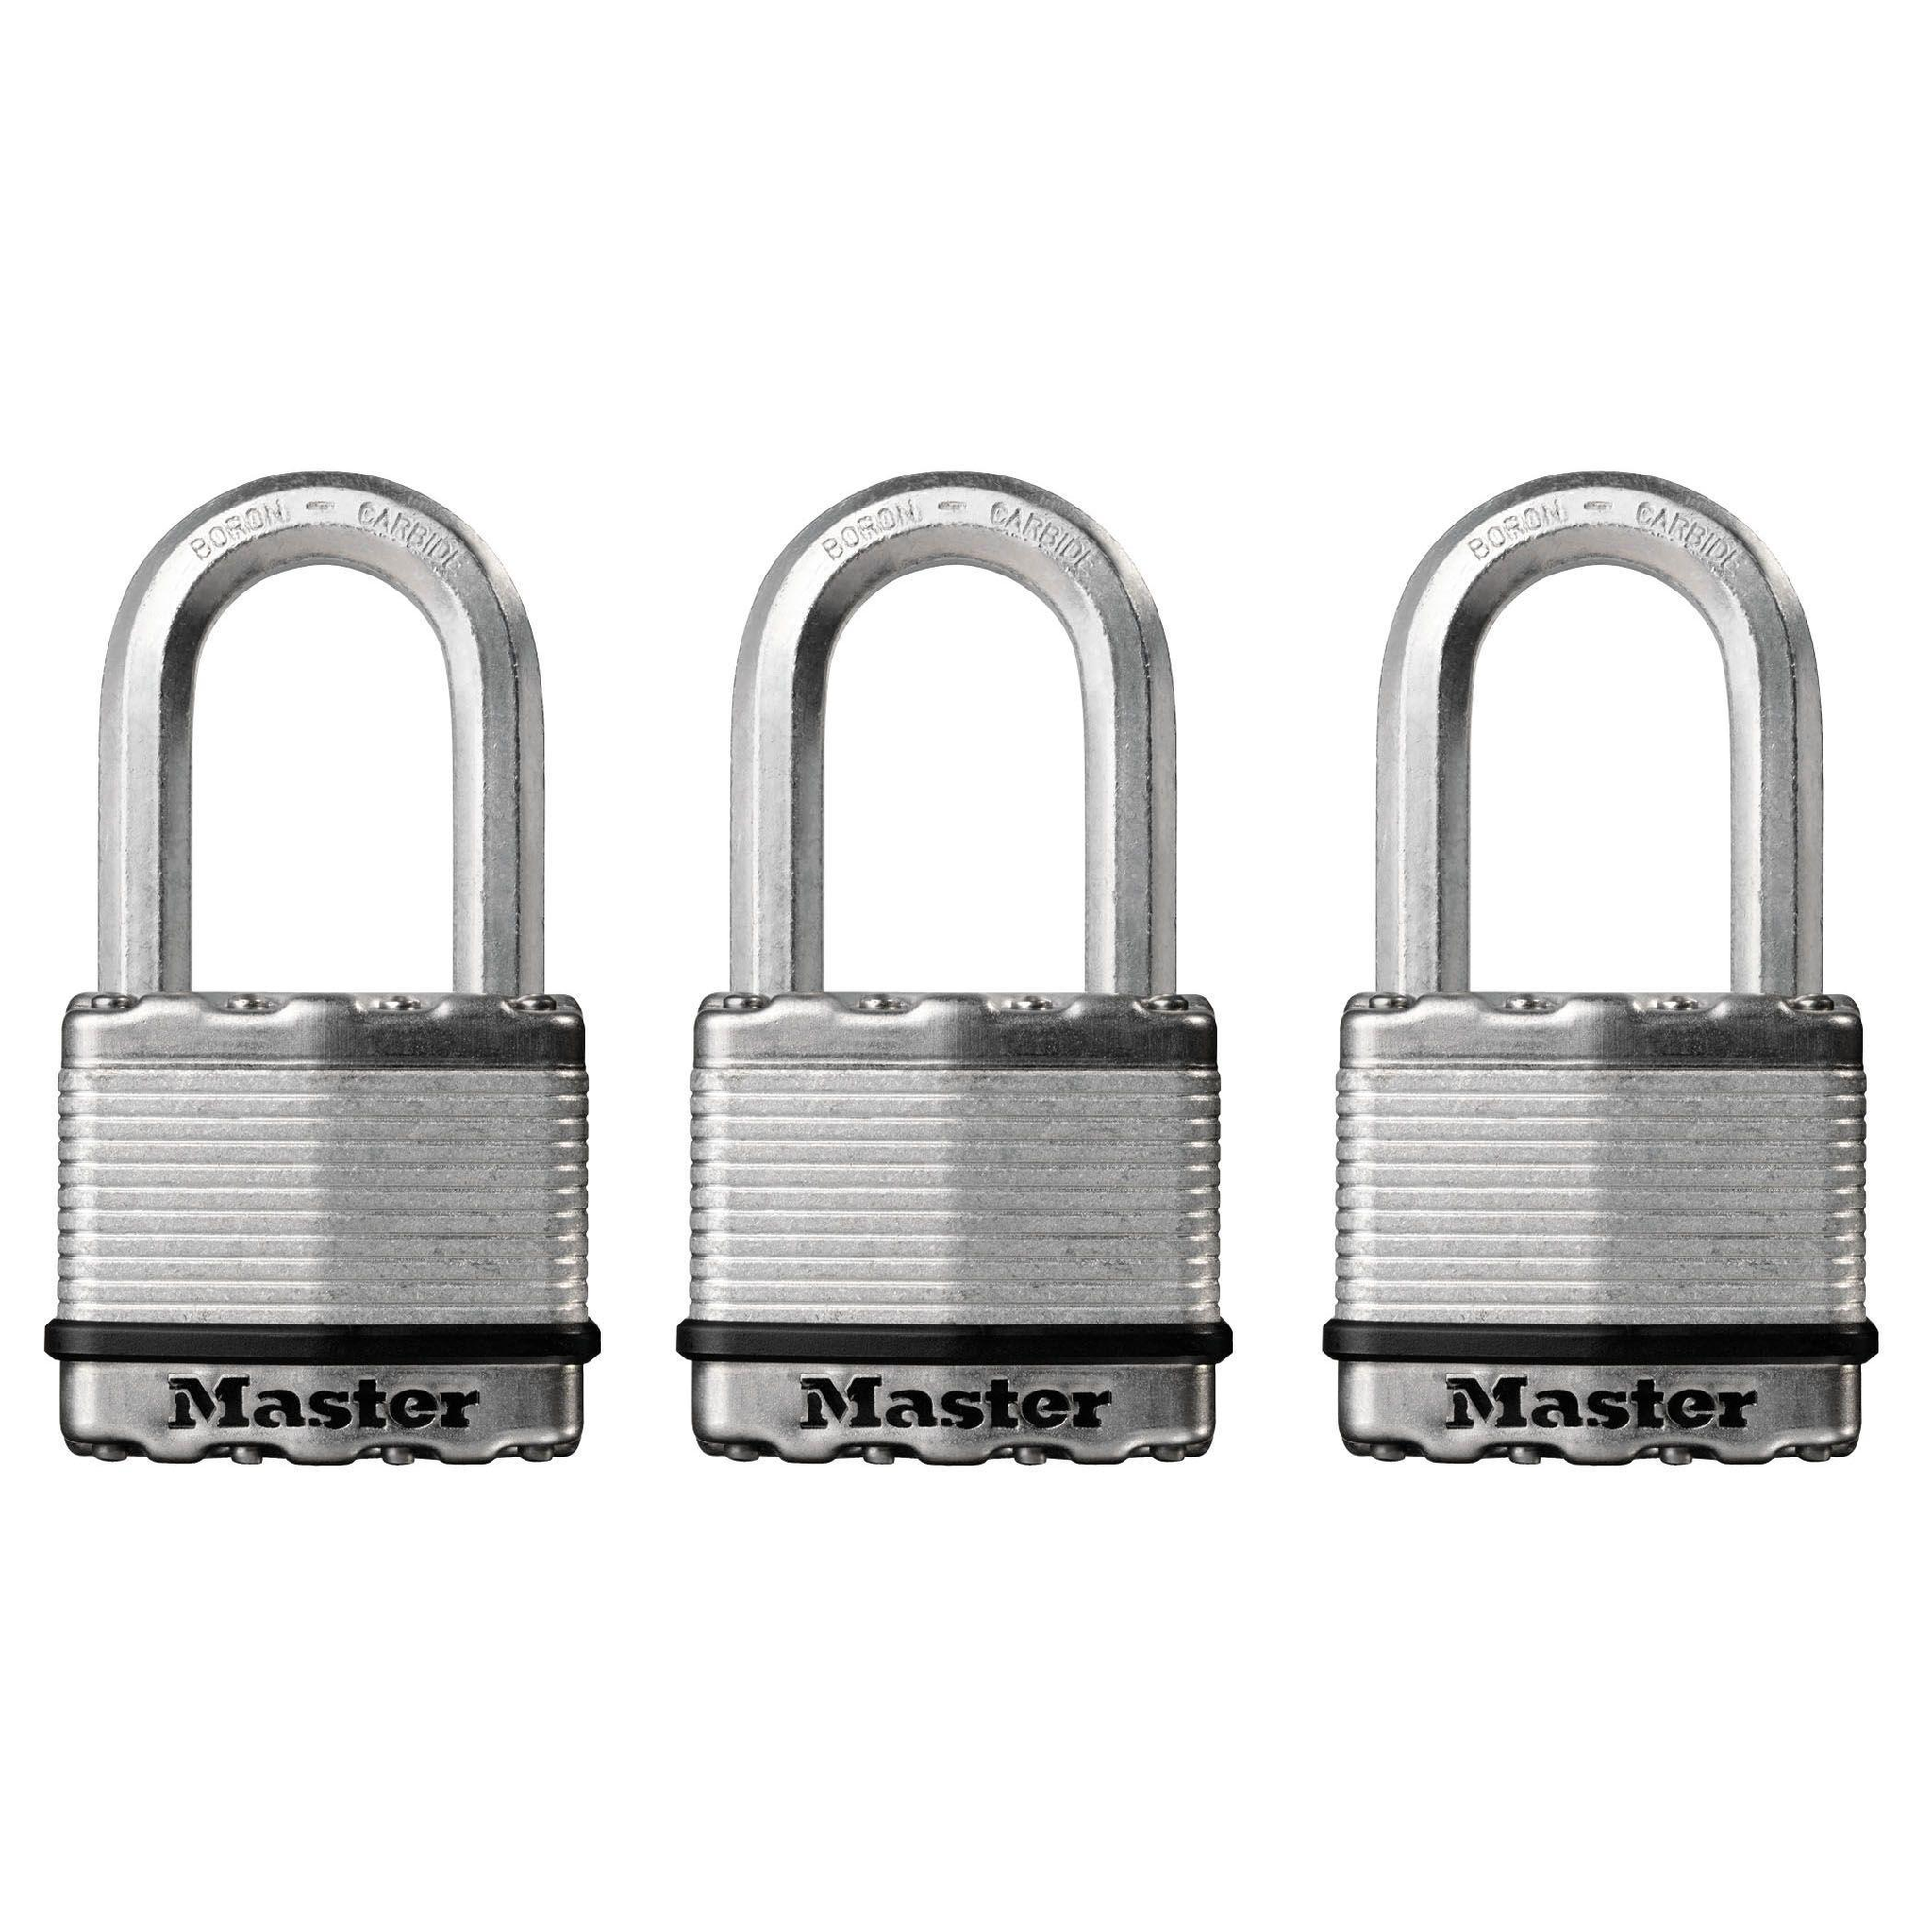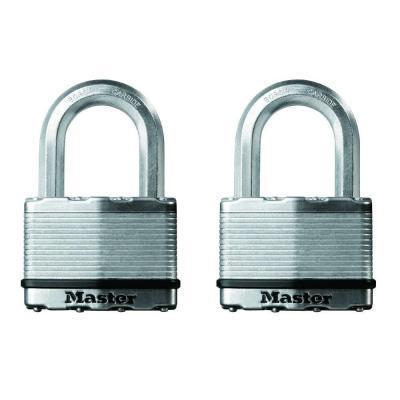The first image is the image on the left, the second image is the image on the right. Examine the images to the left and right. Is the description "There are more locks in the image on the right than in the image on the left." accurate? Answer yes or no. No. The first image is the image on the left, the second image is the image on the right. For the images displayed, is the sentence "An image shows a stack of two black-topped keys next to two overlapping upright black padlocks." factually correct? Answer yes or no. No. 